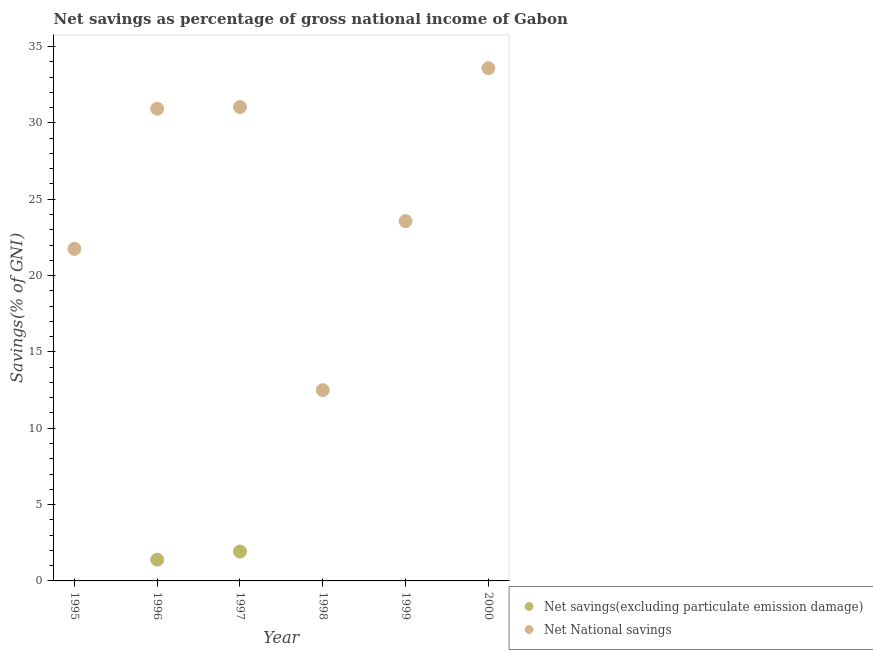Is the number of dotlines equal to the number of legend labels?
Offer a very short reply. No. What is the net national savings in 1999?
Provide a short and direct response. 23.57. Across all years, what is the maximum net national savings?
Your answer should be compact. 33.58. Across all years, what is the minimum net national savings?
Make the answer very short. 12.5. What is the total net savings(excluding particulate emission damage) in the graph?
Keep it short and to the point. 3.32. What is the difference between the net savings(excluding particulate emission damage) in 1996 and that in 1997?
Your response must be concise. -0.53. What is the difference between the net savings(excluding particulate emission damage) in 1999 and the net national savings in 2000?
Your answer should be compact. -33.58. What is the average net national savings per year?
Offer a very short reply. 25.56. In the year 1996, what is the difference between the net national savings and net savings(excluding particulate emission damage)?
Give a very brief answer. 29.54. What is the ratio of the net savings(excluding particulate emission damage) in 1996 to that in 1997?
Offer a very short reply. 0.72. What is the difference between the highest and the second highest net national savings?
Your answer should be compact. 2.54. What is the difference between the highest and the lowest net savings(excluding particulate emission damage)?
Offer a terse response. 1.92. Is the sum of the net national savings in 1997 and 2000 greater than the maximum net savings(excluding particulate emission damage) across all years?
Give a very brief answer. Yes. Does the net savings(excluding particulate emission damage) monotonically increase over the years?
Make the answer very short. No. How many dotlines are there?
Your response must be concise. 2. How many years are there in the graph?
Provide a short and direct response. 6. What is the difference between two consecutive major ticks on the Y-axis?
Your answer should be compact. 5. Does the graph contain any zero values?
Offer a very short reply. Yes. How are the legend labels stacked?
Your answer should be very brief. Vertical. What is the title of the graph?
Provide a succinct answer. Net savings as percentage of gross national income of Gabon. What is the label or title of the X-axis?
Make the answer very short. Year. What is the label or title of the Y-axis?
Make the answer very short. Savings(% of GNI). What is the Savings(% of GNI) in Net savings(excluding particulate emission damage) in 1995?
Your answer should be very brief. 0. What is the Savings(% of GNI) of Net National savings in 1995?
Your response must be concise. 21.75. What is the Savings(% of GNI) of Net savings(excluding particulate emission damage) in 1996?
Make the answer very short. 1.39. What is the Savings(% of GNI) in Net National savings in 1996?
Give a very brief answer. 30.93. What is the Savings(% of GNI) in Net savings(excluding particulate emission damage) in 1997?
Make the answer very short. 1.92. What is the Savings(% of GNI) in Net National savings in 1997?
Make the answer very short. 31.04. What is the Savings(% of GNI) of Net savings(excluding particulate emission damage) in 1998?
Provide a short and direct response. 0. What is the Savings(% of GNI) of Net National savings in 1998?
Make the answer very short. 12.5. What is the Savings(% of GNI) of Net savings(excluding particulate emission damage) in 1999?
Your answer should be very brief. 0. What is the Savings(% of GNI) of Net National savings in 1999?
Keep it short and to the point. 23.57. What is the Savings(% of GNI) in Net National savings in 2000?
Provide a succinct answer. 33.58. Across all years, what is the maximum Savings(% of GNI) in Net savings(excluding particulate emission damage)?
Keep it short and to the point. 1.92. Across all years, what is the maximum Savings(% of GNI) of Net National savings?
Give a very brief answer. 33.58. Across all years, what is the minimum Savings(% of GNI) in Net savings(excluding particulate emission damage)?
Provide a succinct answer. 0. Across all years, what is the minimum Savings(% of GNI) of Net National savings?
Your answer should be compact. 12.5. What is the total Savings(% of GNI) in Net savings(excluding particulate emission damage) in the graph?
Ensure brevity in your answer.  3.32. What is the total Savings(% of GNI) of Net National savings in the graph?
Your answer should be very brief. 153.37. What is the difference between the Savings(% of GNI) of Net National savings in 1995 and that in 1996?
Offer a very short reply. -9.18. What is the difference between the Savings(% of GNI) of Net National savings in 1995 and that in 1997?
Offer a very short reply. -9.29. What is the difference between the Savings(% of GNI) of Net National savings in 1995 and that in 1998?
Ensure brevity in your answer.  9.26. What is the difference between the Savings(% of GNI) of Net National savings in 1995 and that in 1999?
Your response must be concise. -1.82. What is the difference between the Savings(% of GNI) in Net National savings in 1995 and that in 2000?
Keep it short and to the point. -11.83. What is the difference between the Savings(% of GNI) of Net savings(excluding particulate emission damage) in 1996 and that in 1997?
Provide a succinct answer. -0.53. What is the difference between the Savings(% of GNI) in Net National savings in 1996 and that in 1997?
Provide a short and direct response. -0.11. What is the difference between the Savings(% of GNI) in Net National savings in 1996 and that in 1998?
Your response must be concise. 18.43. What is the difference between the Savings(% of GNI) of Net National savings in 1996 and that in 1999?
Give a very brief answer. 7.36. What is the difference between the Savings(% of GNI) of Net National savings in 1996 and that in 2000?
Your answer should be very brief. -2.65. What is the difference between the Savings(% of GNI) of Net National savings in 1997 and that in 1998?
Offer a very short reply. 18.54. What is the difference between the Savings(% of GNI) of Net National savings in 1997 and that in 1999?
Give a very brief answer. 7.47. What is the difference between the Savings(% of GNI) of Net National savings in 1997 and that in 2000?
Your response must be concise. -2.54. What is the difference between the Savings(% of GNI) in Net National savings in 1998 and that in 1999?
Ensure brevity in your answer.  -11.07. What is the difference between the Savings(% of GNI) in Net National savings in 1998 and that in 2000?
Offer a terse response. -21.09. What is the difference between the Savings(% of GNI) of Net National savings in 1999 and that in 2000?
Your answer should be very brief. -10.02. What is the difference between the Savings(% of GNI) in Net savings(excluding particulate emission damage) in 1996 and the Savings(% of GNI) in Net National savings in 1997?
Your answer should be very brief. -29.65. What is the difference between the Savings(% of GNI) in Net savings(excluding particulate emission damage) in 1996 and the Savings(% of GNI) in Net National savings in 1998?
Provide a succinct answer. -11.1. What is the difference between the Savings(% of GNI) of Net savings(excluding particulate emission damage) in 1996 and the Savings(% of GNI) of Net National savings in 1999?
Your answer should be compact. -22.18. What is the difference between the Savings(% of GNI) in Net savings(excluding particulate emission damage) in 1996 and the Savings(% of GNI) in Net National savings in 2000?
Provide a succinct answer. -32.19. What is the difference between the Savings(% of GNI) of Net savings(excluding particulate emission damage) in 1997 and the Savings(% of GNI) of Net National savings in 1998?
Give a very brief answer. -10.57. What is the difference between the Savings(% of GNI) in Net savings(excluding particulate emission damage) in 1997 and the Savings(% of GNI) in Net National savings in 1999?
Provide a succinct answer. -21.64. What is the difference between the Savings(% of GNI) of Net savings(excluding particulate emission damage) in 1997 and the Savings(% of GNI) of Net National savings in 2000?
Offer a terse response. -31.66. What is the average Savings(% of GNI) of Net savings(excluding particulate emission damage) per year?
Keep it short and to the point. 0.55. What is the average Savings(% of GNI) of Net National savings per year?
Offer a terse response. 25.56. In the year 1996, what is the difference between the Savings(% of GNI) of Net savings(excluding particulate emission damage) and Savings(% of GNI) of Net National savings?
Offer a terse response. -29.54. In the year 1997, what is the difference between the Savings(% of GNI) in Net savings(excluding particulate emission damage) and Savings(% of GNI) in Net National savings?
Keep it short and to the point. -29.12. What is the ratio of the Savings(% of GNI) of Net National savings in 1995 to that in 1996?
Offer a very short reply. 0.7. What is the ratio of the Savings(% of GNI) of Net National savings in 1995 to that in 1997?
Offer a very short reply. 0.7. What is the ratio of the Savings(% of GNI) in Net National savings in 1995 to that in 1998?
Your response must be concise. 1.74. What is the ratio of the Savings(% of GNI) in Net National savings in 1995 to that in 1999?
Your answer should be very brief. 0.92. What is the ratio of the Savings(% of GNI) in Net National savings in 1995 to that in 2000?
Your answer should be compact. 0.65. What is the ratio of the Savings(% of GNI) of Net savings(excluding particulate emission damage) in 1996 to that in 1997?
Your answer should be very brief. 0.72. What is the ratio of the Savings(% of GNI) of Net National savings in 1996 to that in 1997?
Your response must be concise. 1. What is the ratio of the Savings(% of GNI) in Net National savings in 1996 to that in 1998?
Give a very brief answer. 2.48. What is the ratio of the Savings(% of GNI) in Net National savings in 1996 to that in 1999?
Your answer should be very brief. 1.31. What is the ratio of the Savings(% of GNI) of Net National savings in 1996 to that in 2000?
Give a very brief answer. 0.92. What is the ratio of the Savings(% of GNI) of Net National savings in 1997 to that in 1998?
Ensure brevity in your answer.  2.48. What is the ratio of the Savings(% of GNI) of Net National savings in 1997 to that in 1999?
Give a very brief answer. 1.32. What is the ratio of the Savings(% of GNI) of Net National savings in 1997 to that in 2000?
Offer a terse response. 0.92. What is the ratio of the Savings(% of GNI) of Net National savings in 1998 to that in 1999?
Offer a terse response. 0.53. What is the ratio of the Savings(% of GNI) of Net National savings in 1998 to that in 2000?
Your response must be concise. 0.37. What is the ratio of the Savings(% of GNI) of Net National savings in 1999 to that in 2000?
Give a very brief answer. 0.7. What is the difference between the highest and the second highest Savings(% of GNI) of Net National savings?
Provide a succinct answer. 2.54. What is the difference between the highest and the lowest Savings(% of GNI) of Net savings(excluding particulate emission damage)?
Give a very brief answer. 1.92. What is the difference between the highest and the lowest Savings(% of GNI) of Net National savings?
Make the answer very short. 21.09. 